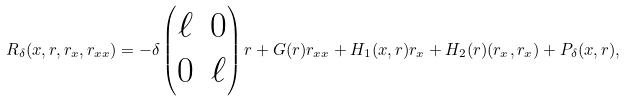Convert formula to latex. <formula><loc_0><loc_0><loc_500><loc_500>R _ { \delta } ( x , r , r _ { x } , r _ { x x } ) = - \delta \begin{pmatrix} \ell & 0 \\ 0 & \ell \end{pmatrix} r + G ( r ) r _ { x x } + H _ { 1 } ( x , r ) r _ { x } + H _ { 2 } ( r ) ( r _ { x } , r _ { x } ) + P _ { \delta } ( x , r ) ,</formula> 